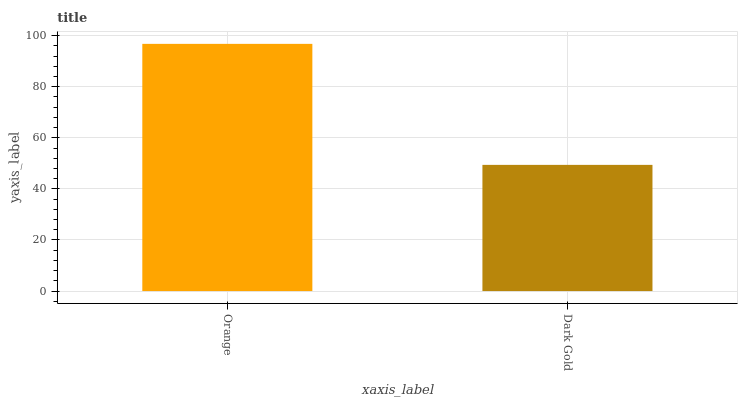Is Dark Gold the maximum?
Answer yes or no. No. Is Orange greater than Dark Gold?
Answer yes or no. Yes. Is Dark Gold less than Orange?
Answer yes or no. Yes. Is Dark Gold greater than Orange?
Answer yes or no. No. Is Orange less than Dark Gold?
Answer yes or no. No. Is Orange the high median?
Answer yes or no. Yes. Is Dark Gold the low median?
Answer yes or no. Yes. Is Dark Gold the high median?
Answer yes or no. No. Is Orange the low median?
Answer yes or no. No. 